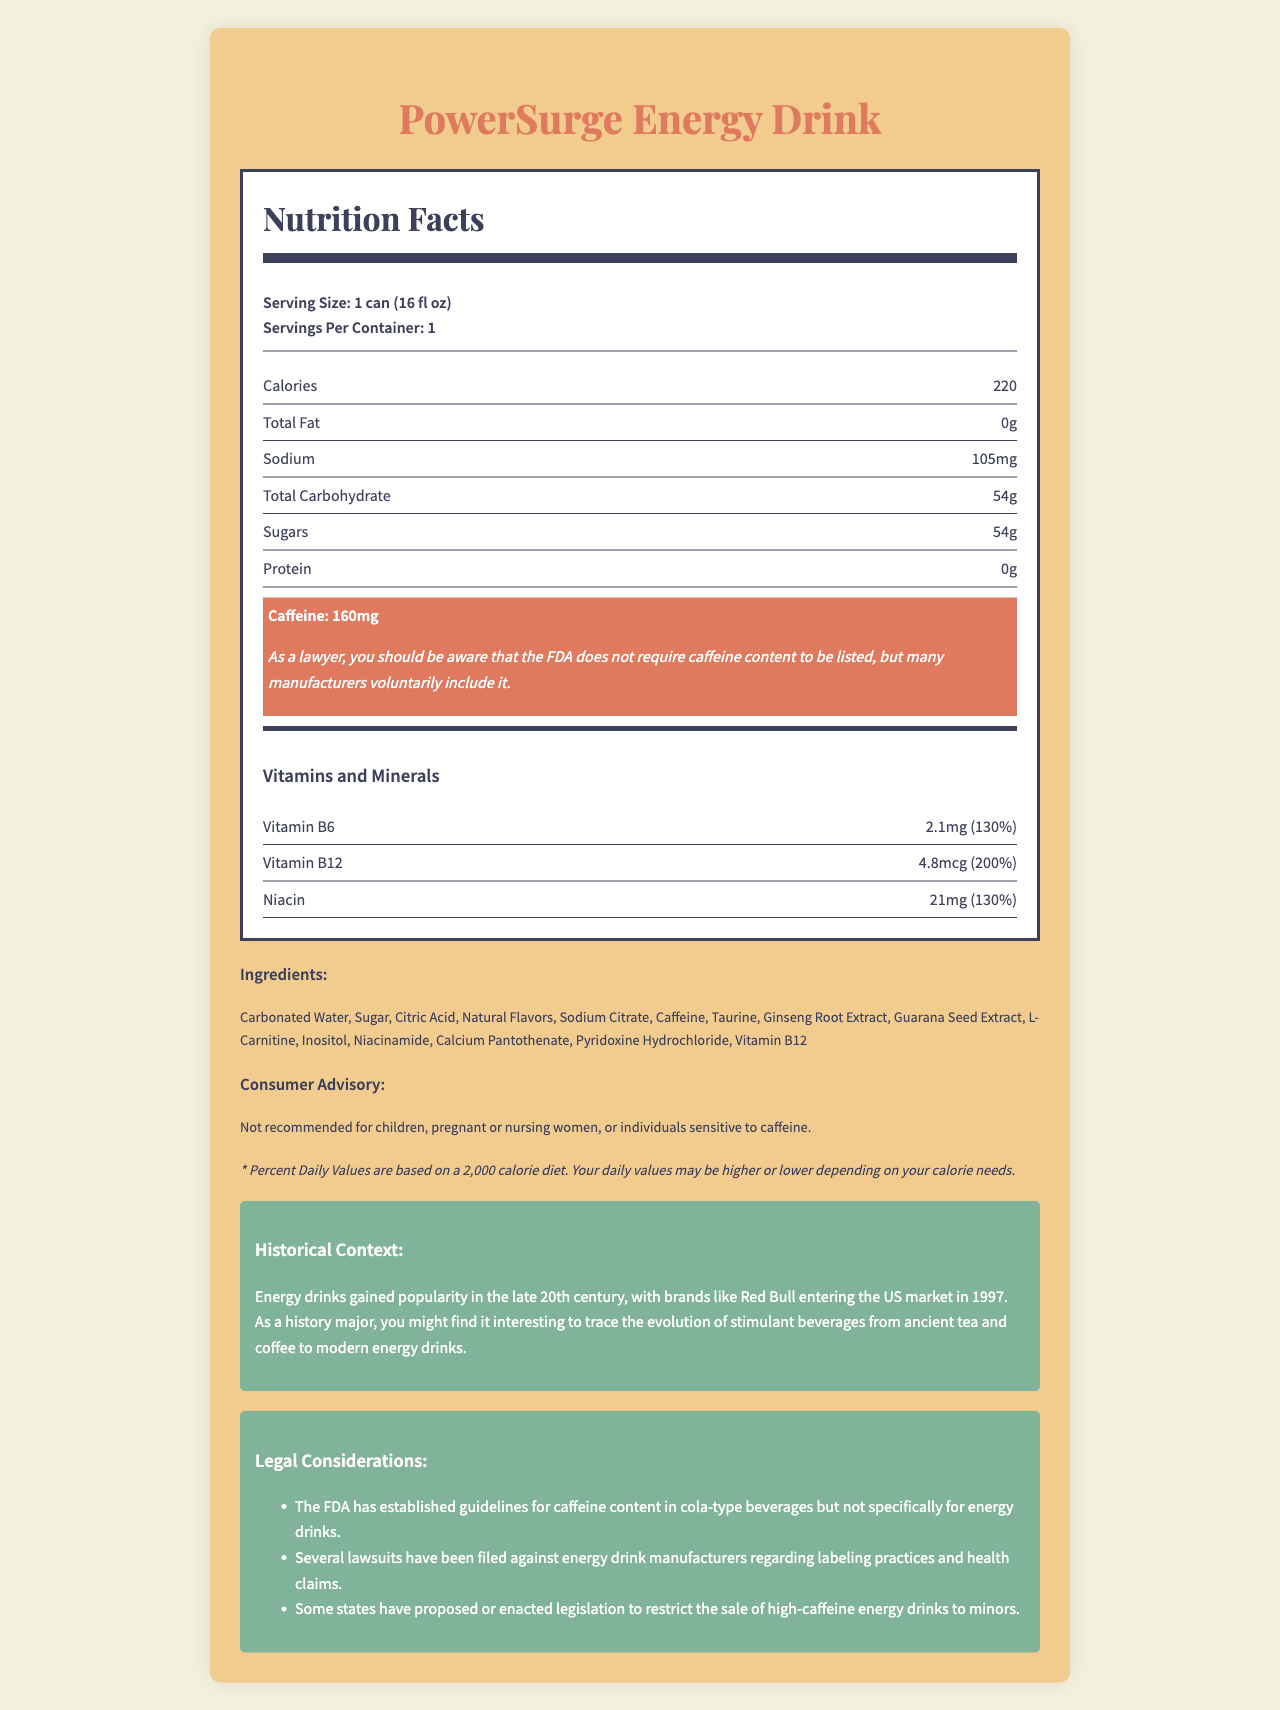What is the serving size of PowerSurge Energy Drink? The serving size is listed at the top of the Nutrition Facts section as "Serving Size: 1 can (16 fl oz)".
Answer: 1 can (16 fl oz) How many calories are in one serving of the energy drink? The calorie content is specified in the nutritional information as "Calories 220".
Answer: 220 What is the total carbohydrate content per serving? The total carbohydrate content per serving is listed as "Total Carbohydrate 54g".
Answer: 54g How much caffeine is in one can of PowerSurge Energy Drink? The caffeine content is highlighted in the nutritional label as "Caffeine: 160mg".
Answer: 160mg What vitamins and minerals are included in PowerSurge Energy Drink? The vitamins and minerals section lists "Vitamin B6, Vitamin B12, Niacin".
Answer: Vitamin B6, Vitamin B12, Niacin How much sodium is present in one serving? The sodium content is specified in the nutritional information as "Sodium 105mg".
Answer: 105mg What does the consumer advisory warn against? The consumer advisory states: "Not recommended for children, pregnant or nursing women, or individuals sensitive to caffeine."
Answer: Not recommended for children, pregnant or nursing women, or individuals sensitive to caffeine. What historical context is provided about energy drinks? The historical context section explains: "Energy drinks gained popularity in the late 20th century, with brands like Red Bull entering the US market in 1997."
Answer: Energy drinks gained popularity in the late 20th century, with brands like Red Bull entering the US market in 1997. Which vitamin provides the highest percent daily value? A. Vitamin B6 B. Vitamin B12 C. Niacin The daily value percentages listed are Vitamin B6 (130%), Vitamin B12 (200%), and Niacin (130%), making Vitamin B12 the highest.
Answer: B. Vitamin B12 What are some potential legal considerations related to energy drinks? A. Restriction to minors B. Mandatory labeling of caffeine content C. Established FDA guidelines for energy drinks The document lists legal considerations which include restriction of sale to minors and established FDA guidelines for cola-type beverages, not specifically for energy drinks.
Answer: A. Restriction to minors Does PowerSurge Energy Drink contain any fat? The document states "Total Fat: 0g," indicating there is no fat content.
Answer: No Summarize the key nutritional facts and context about PowerSurge Energy Drink. The document provides detailed nutritional information on PowerSurge Energy Drink, highlighting its carbohydrate and caffeine content, vitamins, and consumer advisories. It also contextualizes the drink in terms of its market history and relevant legal guidelines.
Answer: PowerSurge Energy Drink contains 220 calories, 0g fat, 105mg sodium, 54g carbohydrates (all sugars), 0g protein, and 160mg caffeine, along with significant amounts of Vitamin B6, B12, and Niacin. It warns against consumption by children, pregnant or nursing women, and those sensitive to caffeine. There are also legal considerations for caffeine content and marketing, and a historical note on the popularity of energy drinks. What is the primary ingredient in the PowerSurge Energy Drink? The document lists all ingredients but does not specify which one is the primary ingredient.
Answer: Not enough information Are there any established FDA guidelines for caffeine content in energy drinks? The document mentions that the "FDA has established guidelines for caffeine content in cola-type beverages but not specifically for energy drinks."
Answer: No 